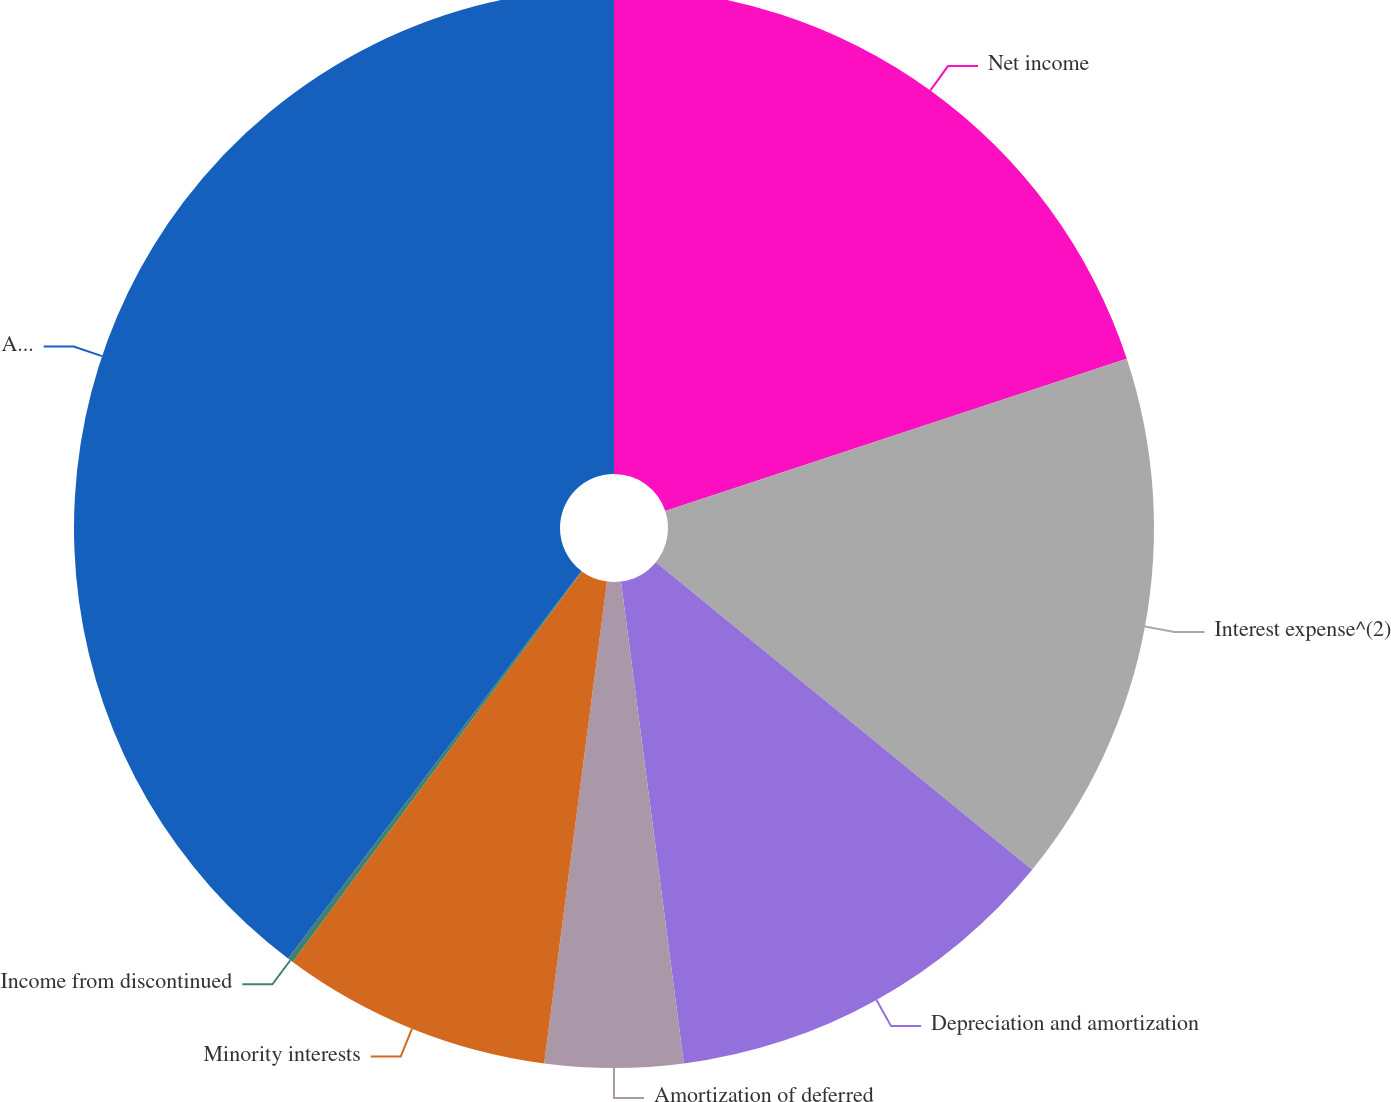Convert chart. <chart><loc_0><loc_0><loc_500><loc_500><pie_chart><fcel>Net income<fcel>Interest expense^(2)<fcel>Depreciation and amortization<fcel>Amortization of deferred<fcel>Minority interests<fcel>Income from discontinued<fcel>Adjusted EBITDA^(3)<nl><fcel>19.93%<fcel>15.98%<fcel>12.03%<fcel>4.13%<fcel>8.08%<fcel>0.17%<fcel>39.69%<nl></chart> 